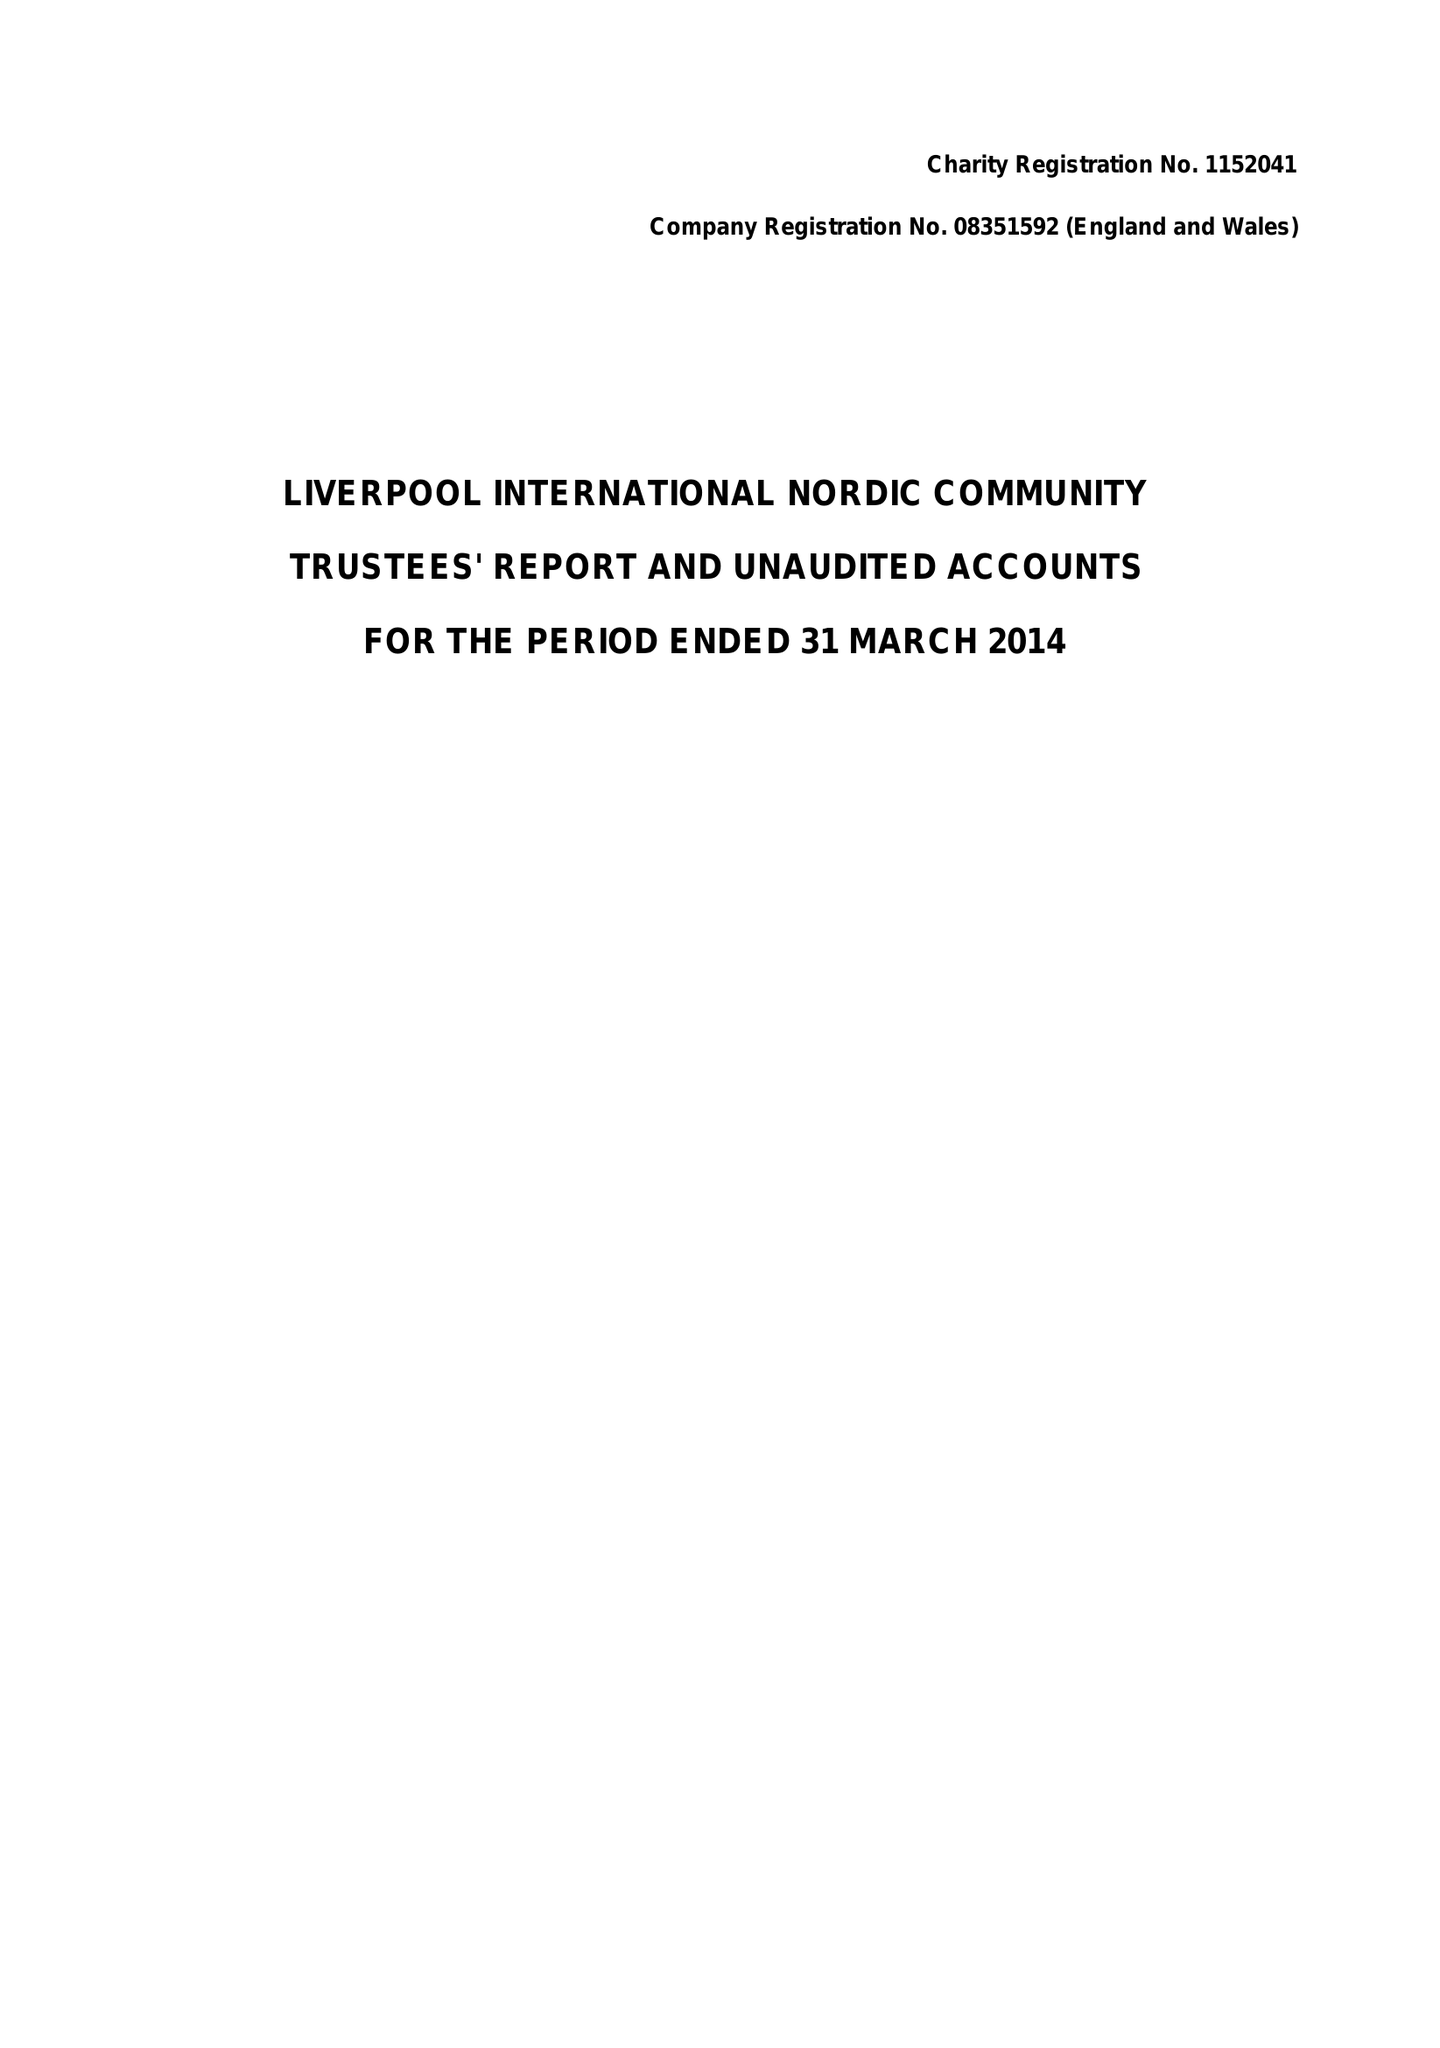What is the value for the charity_number?
Answer the question using a single word or phrase. 1152041 